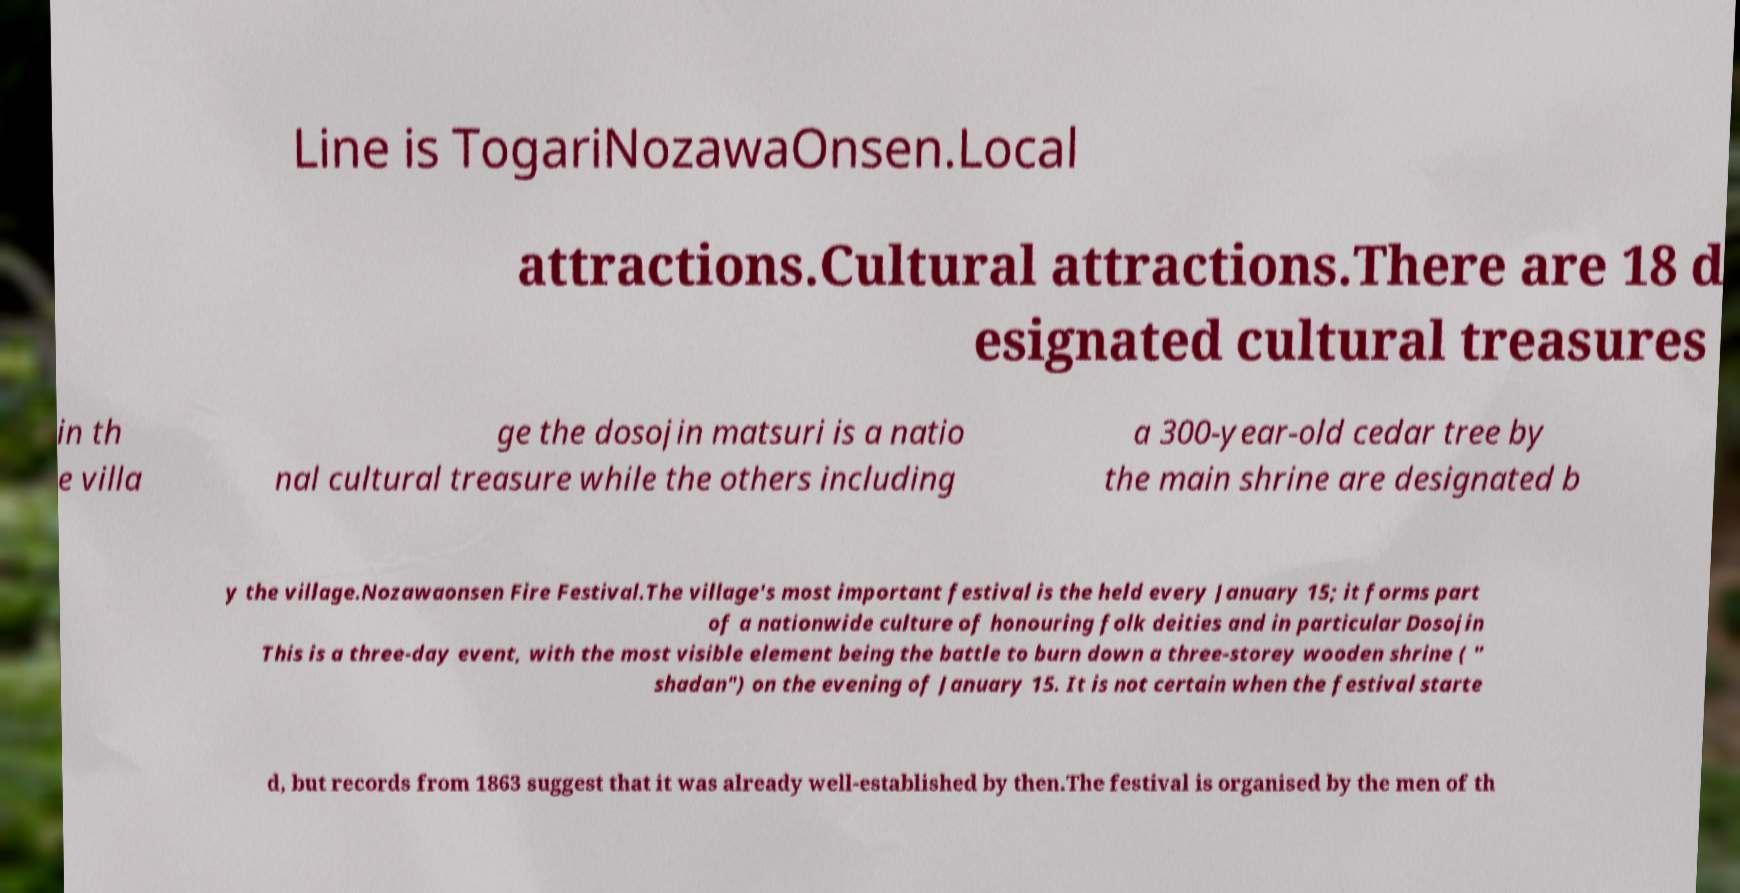Please read and relay the text visible in this image. What does it say? Line is TogariNozawaOnsen.Local attractions.Cultural attractions.There are 18 d esignated cultural treasures in th e villa ge the dosojin matsuri is a natio nal cultural treasure while the others including a 300-year-old cedar tree by the main shrine are designated b y the village.Nozawaonsen Fire Festival.The village's most important festival is the held every January 15; it forms part of a nationwide culture of honouring folk deities and in particular Dosojin This is a three-day event, with the most visible element being the battle to burn down a three-storey wooden shrine ( " shadan") on the evening of January 15. It is not certain when the festival starte d, but records from 1863 suggest that it was already well-established by then.The festival is organised by the men of th 